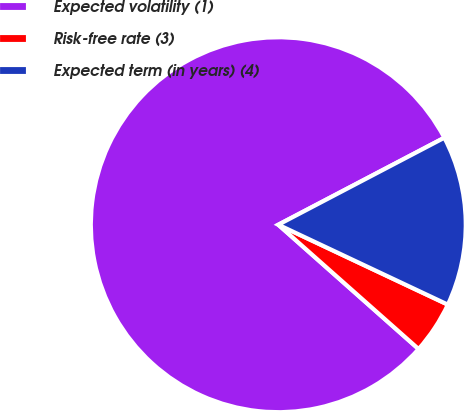Convert chart to OTSL. <chart><loc_0><loc_0><loc_500><loc_500><pie_chart><fcel>Expected volatility (1)<fcel>Risk-free rate (3)<fcel>Expected term (in years) (4)<nl><fcel>80.78%<fcel>4.53%<fcel>14.69%<nl></chart> 